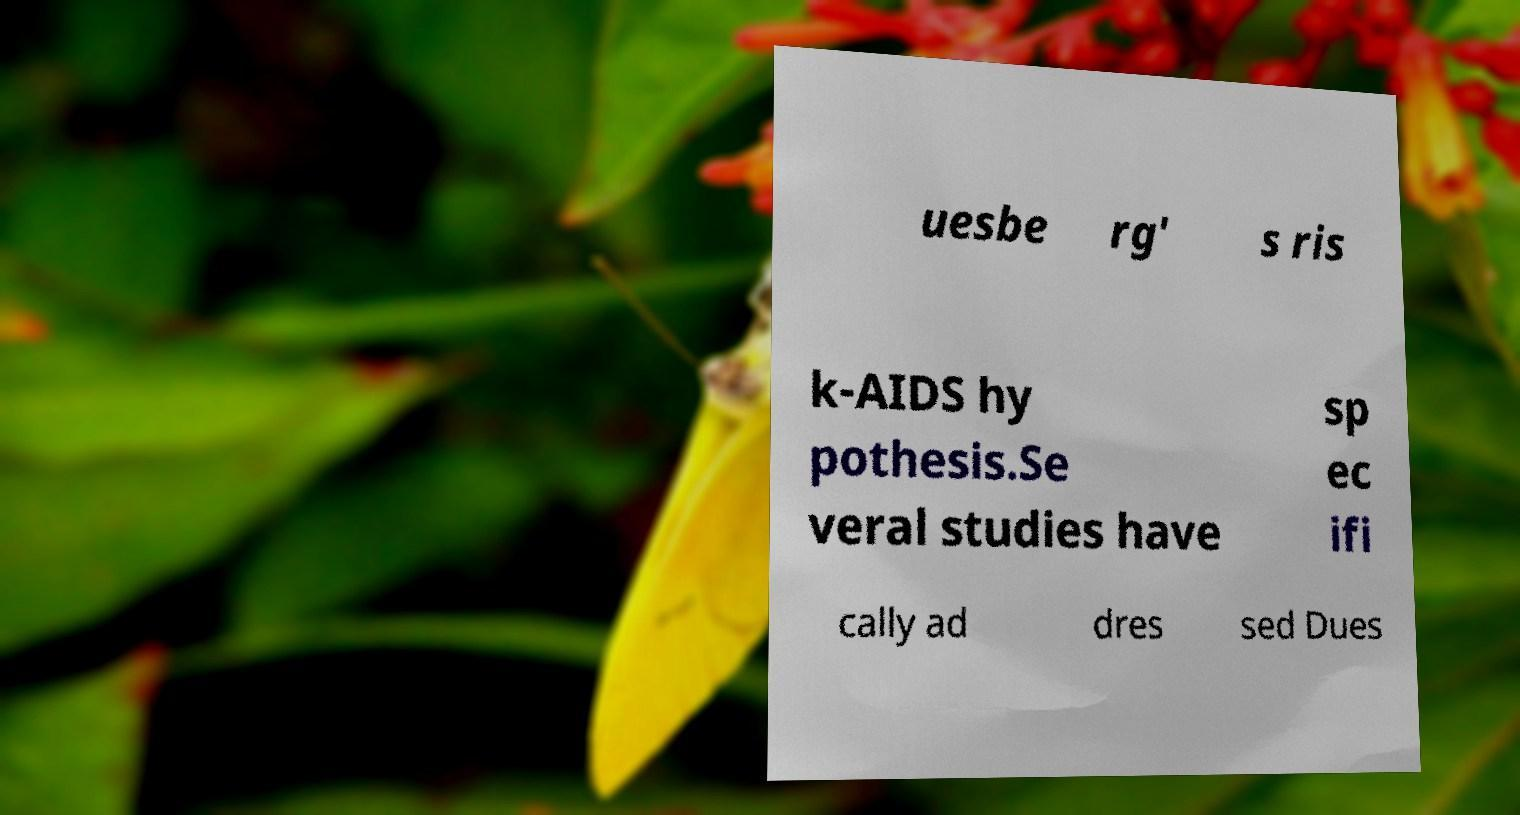What messages or text are displayed in this image? I need them in a readable, typed format. uesbe rg' s ris k-AIDS hy pothesis.Se veral studies have sp ec ifi cally ad dres sed Dues 